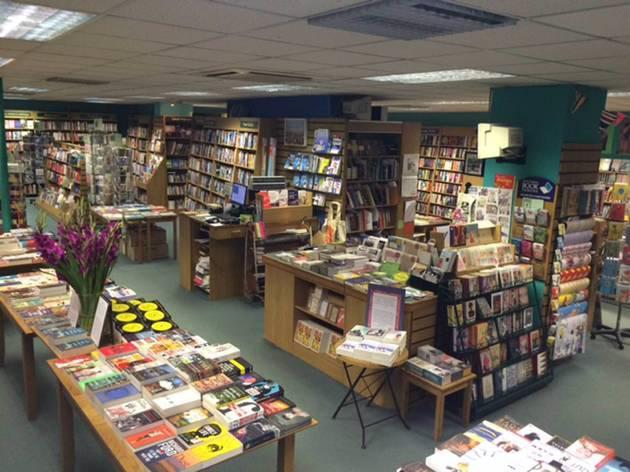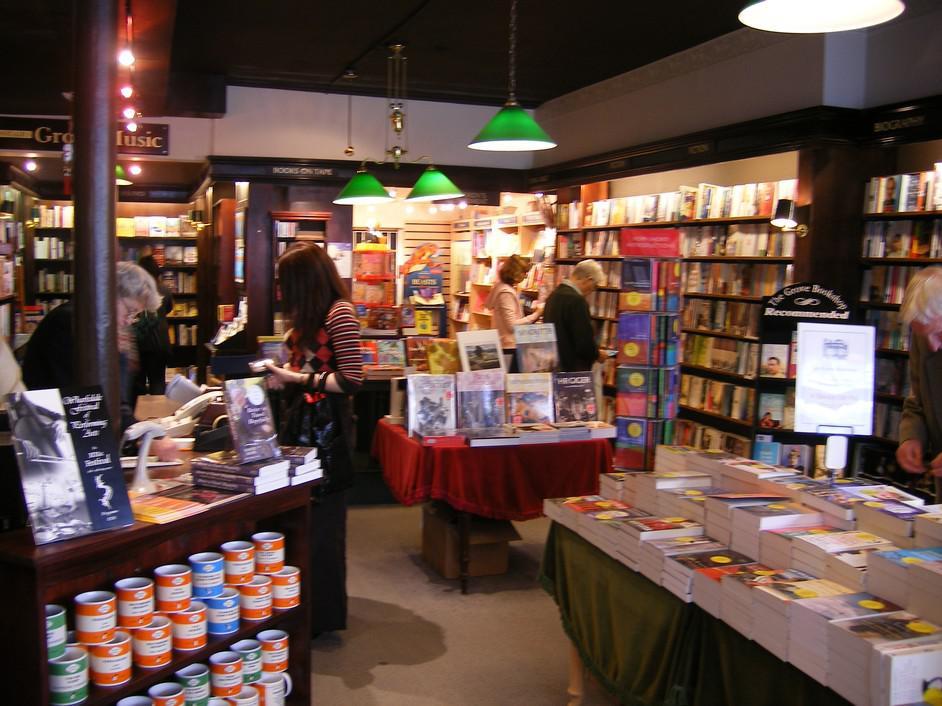The first image is the image on the left, the second image is the image on the right. Examine the images to the left and right. Is the description "There are three or more people shopping for books in the left image." accurate? Answer yes or no. No. The first image is the image on the left, the second image is the image on the right. For the images shown, is this caption "A wall in one image has windows that show a glimpse of outside the bookshop." true? Answer yes or no. No. 